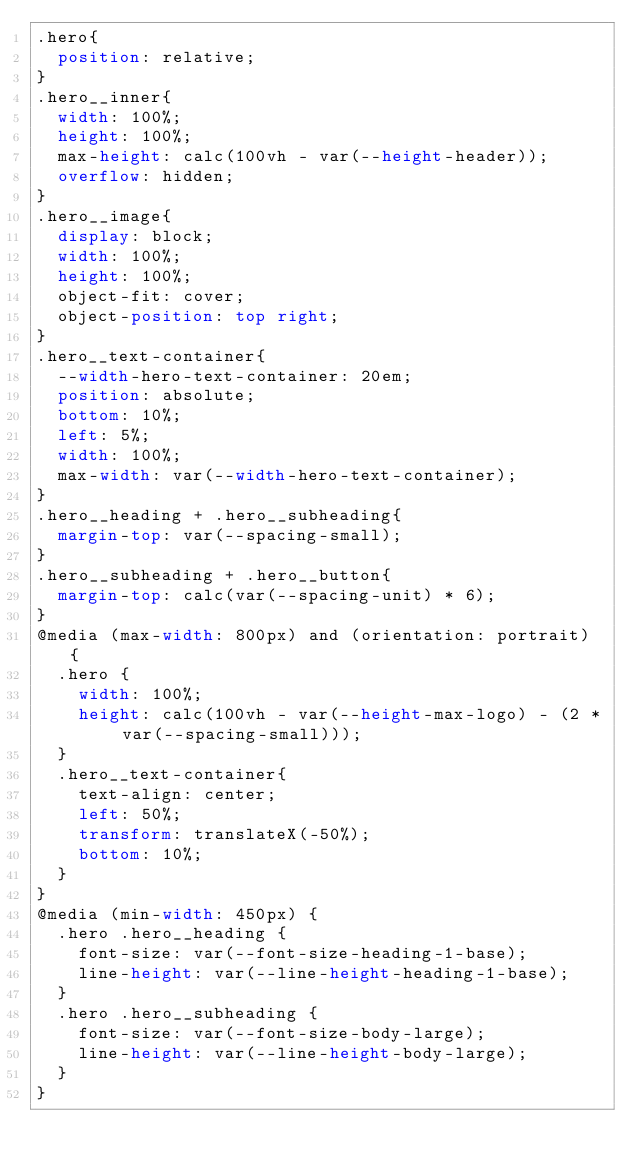<code> <loc_0><loc_0><loc_500><loc_500><_CSS_>.hero{
  position: relative;
}
.hero__inner{
  width: 100%;
  height: 100%;
  max-height: calc(100vh - var(--height-header));
  overflow: hidden;
}
.hero__image{
  display: block;
  width: 100%;
  height: 100%;
  object-fit: cover;
  object-position: top right;
}
.hero__text-container{
  --width-hero-text-container: 20em;
  position: absolute;
  bottom: 10%;
  left: 5%;
  width: 100%;
  max-width: var(--width-hero-text-container);
}
.hero__heading + .hero__subheading{
  margin-top: var(--spacing-small);
}
.hero__subheading + .hero__button{
  margin-top: calc(var(--spacing-unit) * 6);
}
@media (max-width: 800px) and (orientation: portrait) {
  .hero {
    width: 100%;
    height: calc(100vh - var(--height-max-logo) - (2 * var(--spacing-small)));
  }
  .hero__text-container{
    text-align: center;
    left: 50%;
    transform: translateX(-50%);
    bottom: 10%;
  }
}
@media (min-width: 450px) {
  .hero .hero__heading {
    font-size: var(--font-size-heading-1-base);
    line-height: var(--line-height-heading-1-base);
  }
  .hero .hero__subheading {
    font-size: var(--font-size-body-large);
    line-height: var(--line-height-body-large);
  }
}
</code> 